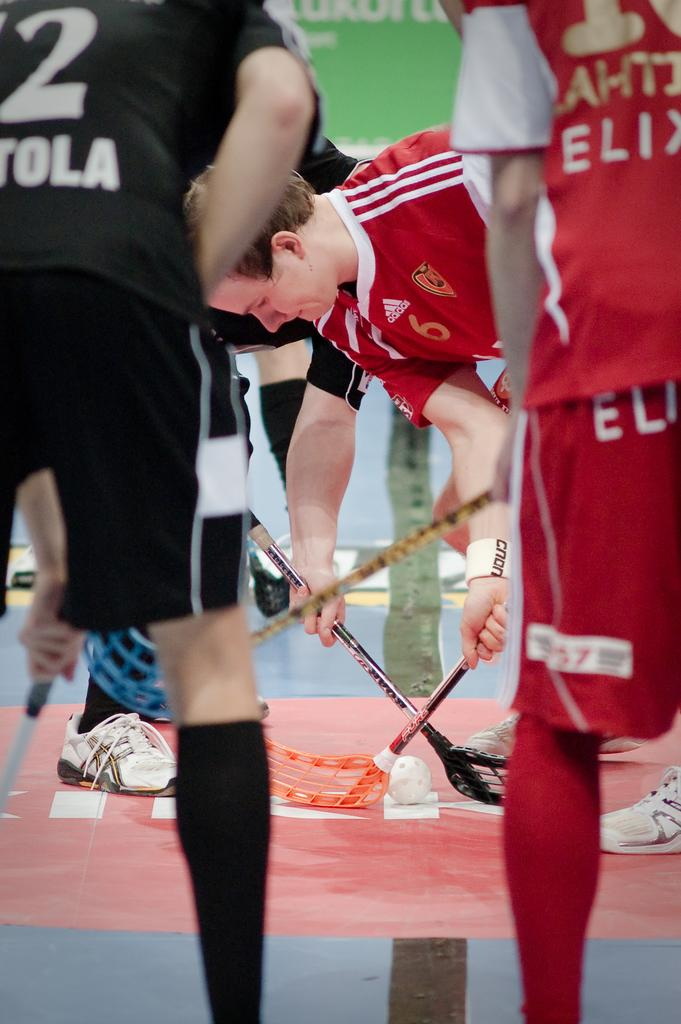Provide a one-sentence caption for the provided image. A man prepares to start the game while wearing a red Adidas jersey. 